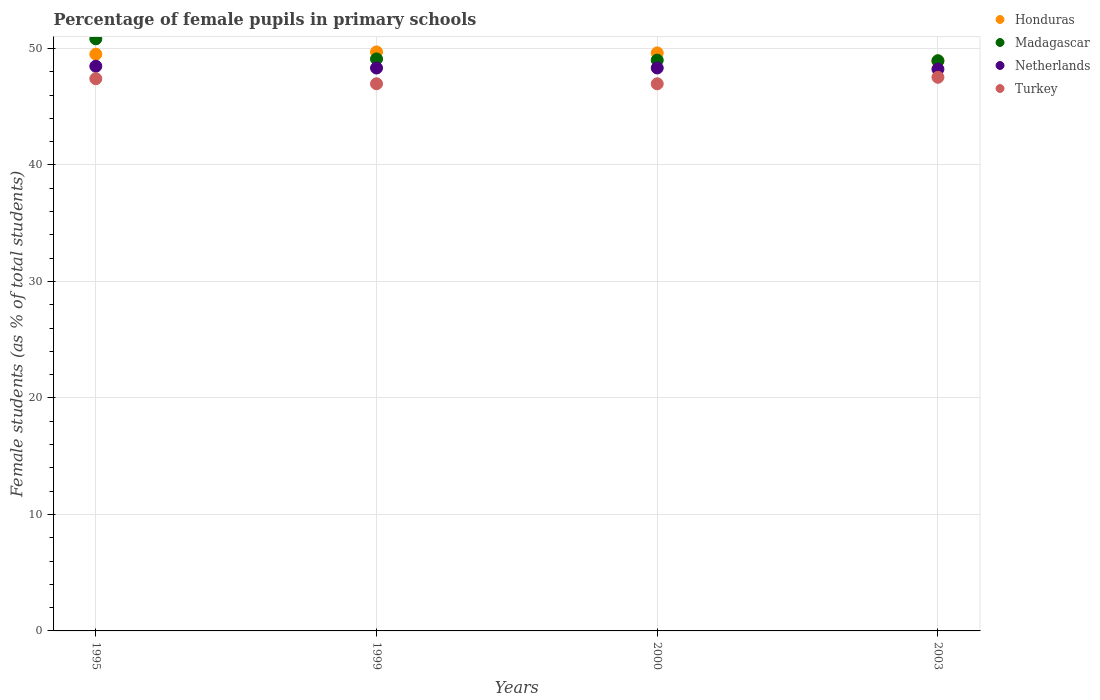How many different coloured dotlines are there?
Make the answer very short. 4. What is the percentage of female pupils in primary schools in Honduras in 1995?
Offer a terse response. 49.51. Across all years, what is the maximum percentage of female pupils in primary schools in Netherlands?
Offer a terse response. 48.47. Across all years, what is the minimum percentage of female pupils in primary schools in Honduras?
Provide a succinct answer. 48.92. In which year was the percentage of female pupils in primary schools in Turkey maximum?
Offer a very short reply. 2003. In which year was the percentage of female pupils in primary schools in Honduras minimum?
Keep it short and to the point. 2003. What is the total percentage of female pupils in primary schools in Turkey in the graph?
Provide a succinct answer. 188.87. What is the difference between the percentage of female pupils in primary schools in Turkey in 1995 and that in 2000?
Your answer should be very brief. 0.44. What is the difference between the percentage of female pupils in primary schools in Turkey in 1995 and the percentage of female pupils in primary schools in Honduras in 2000?
Provide a succinct answer. -2.21. What is the average percentage of female pupils in primary schools in Turkey per year?
Your answer should be compact. 47.22. In the year 1999, what is the difference between the percentage of female pupils in primary schools in Madagascar and percentage of female pupils in primary schools in Honduras?
Provide a short and direct response. -0.6. In how many years, is the percentage of female pupils in primary schools in Netherlands greater than 26 %?
Your answer should be very brief. 4. What is the ratio of the percentage of female pupils in primary schools in Turkey in 1995 to that in 2000?
Your response must be concise. 1.01. What is the difference between the highest and the second highest percentage of female pupils in primary schools in Honduras?
Your answer should be compact. 0.08. What is the difference between the highest and the lowest percentage of female pupils in primary schools in Turkey?
Give a very brief answer. 0.56. Is it the case that in every year, the sum of the percentage of female pupils in primary schools in Turkey and percentage of female pupils in primary schools in Honduras  is greater than the sum of percentage of female pupils in primary schools in Netherlands and percentage of female pupils in primary schools in Madagascar?
Your answer should be compact. No. Is it the case that in every year, the sum of the percentage of female pupils in primary schools in Madagascar and percentage of female pupils in primary schools in Honduras  is greater than the percentage of female pupils in primary schools in Netherlands?
Make the answer very short. Yes. Does the percentage of female pupils in primary schools in Turkey monotonically increase over the years?
Give a very brief answer. No. How many dotlines are there?
Make the answer very short. 4. How many years are there in the graph?
Your answer should be compact. 4. What is the difference between two consecutive major ticks on the Y-axis?
Offer a terse response. 10. Are the values on the major ticks of Y-axis written in scientific E-notation?
Provide a short and direct response. No. Does the graph contain any zero values?
Your response must be concise. No. How are the legend labels stacked?
Offer a terse response. Vertical. What is the title of the graph?
Your answer should be compact. Percentage of female pupils in primary schools. What is the label or title of the X-axis?
Give a very brief answer. Years. What is the label or title of the Y-axis?
Offer a terse response. Female students (as % of total students). What is the Female students (as % of total students) in Honduras in 1995?
Ensure brevity in your answer.  49.51. What is the Female students (as % of total students) of Madagascar in 1995?
Offer a very short reply. 50.83. What is the Female students (as % of total students) of Netherlands in 1995?
Your answer should be compact. 48.47. What is the Female students (as % of total students) of Turkey in 1995?
Provide a short and direct response. 47.4. What is the Female students (as % of total students) in Honduras in 1999?
Ensure brevity in your answer.  49.7. What is the Female students (as % of total students) of Madagascar in 1999?
Keep it short and to the point. 49.1. What is the Female students (as % of total students) of Netherlands in 1999?
Keep it short and to the point. 48.32. What is the Female students (as % of total students) in Turkey in 1999?
Make the answer very short. 46.97. What is the Female students (as % of total students) in Honduras in 2000?
Your response must be concise. 49.62. What is the Female students (as % of total students) of Madagascar in 2000?
Provide a short and direct response. 49. What is the Female students (as % of total students) in Netherlands in 2000?
Your response must be concise. 48.33. What is the Female students (as % of total students) of Turkey in 2000?
Your answer should be very brief. 46.97. What is the Female students (as % of total students) of Honduras in 2003?
Your answer should be very brief. 48.92. What is the Female students (as % of total students) in Madagascar in 2003?
Your response must be concise. 48.95. What is the Female students (as % of total students) in Netherlands in 2003?
Offer a terse response. 48.22. What is the Female students (as % of total students) of Turkey in 2003?
Your answer should be very brief. 47.53. Across all years, what is the maximum Female students (as % of total students) of Honduras?
Offer a terse response. 49.7. Across all years, what is the maximum Female students (as % of total students) of Madagascar?
Ensure brevity in your answer.  50.83. Across all years, what is the maximum Female students (as % of total students) in Netherlands?
Your answer should be compact. 48.47. Across all years, what is the maximum Female students (as % of total students) of Turkey?
Make the answer very short. 47.53. Across all years, what is the minimum Female students (as % of total students) in Honduras?
Offer a terse response. 48.92. Across all years, what is the minimum Female students (as % of total students) of Madagascar?
Ensure brevity in your answer.  48.95. Across all years, what is the minimum Female students (as % of total students) in Netherlands?
Keep it short and to the point. 48.22. Across all years, what is the minimum Female students (as % of total students) of Turkey?
Your answer should be compact. 46.97. What is the total Female students (as % of total students) of Honduras in the graph?
Make the answer very short. 197.75. What is the total Female students (as % of total students) in Madagascar in the graph?
Your answer should be very brief. 197.87. What is the total Female students (as % of total students) in Netherlands in the graph?
Provide a succinct answer. 193.35. What is the total Female students (as % of total students) of Turkey in the graph?
Make the answer very short. 188.87. What is the difference between the Female students (as % of total students) of Honduras in 1995 and that in 1999?
Your response must be concise. -0.19. What is the difference between the Female students (as % of total students) in Madagascar in 1995 and that in 1999?
Your response must be concise. 1.73. What is the difference between the Female students (as % of total students) of Netherlands in 1995 and that in 1999?
Your answer should be compact. 0.15. What is the difference between the Female students (as % of total students) of Turkey in 1995 and that in 1999?
Ensure brevity in your answer.  0.43. What is the difference between the Female students (as % of total students) in Honduras in 1995 and that in 2000?
Give a very brief answer. -0.11. What is the difference between the Female students (as % of total students) of Madagascar in 1995 and that in 2000?
Provide a succinct answer. 1.83. What is the difference between the Female students (as % of total students) in Netherlands in 1995 and that in 2000?
Keep it short and to the point. 0.15. What is the difference between the Female students (as % of total students) in Turkey in 1995 and that in 2000?
Your answer should be compact. 0.44. What is the difference between the Female students (as % of total students) of Honduras in 1995 and that in 2003?
Your answer should be very brief. 0.59. What is the difference between the Female students (as % of total students) in Madagascar in 1995 and that in 2003?
Provide a short and direct response. 1.88. What is the difference between the Female students (as % of total students) in Netherlands in 1995 and that in 2003?
Make the answer very short. 0.25. What is the difference between the Female students (as % of total students) in Turkey in 1995 and that in 2003?
Your response must be concise. -0.12. What is the difference between the Female students (as % of total students) of Honduras in 1999 and that in 2000?
Make the answer very short. 0.08. What is the difference between the Female students (as % of total students) of Madagascar in 1999 and that in 2000?
Make the answer very short. 0.1. What is the difference between the Female students (as % of total students) of Netherlands in 1999 and that in 2000?
Provide a succinct answer. -0. What is the difference between the Female students (as % of total students) of Turkey in 1999 and that in 2000?
Offer a terse response. 0. What is the difference between the Female students (as % of total students) of Honduras in 1999 and that in 2003?
Provide a succinct answer. 0.78. What is the difference between the Female students (as % of total students) in Madagascar in 1999 and that in 2003?
Keep it short and to the point. 0.16. What is the difference between the Female students (as % of total students) in Netherlands in 1999 and that in 2003?
Keep it short and to the point. 0.1. What is the difference between the Female students (as % of total students) in Turkey in 1999 and that in 2003?
Offer a very short reply. -0.56. What is the difference between the Female students (as % of total students) in Honduras in 2000 and that in 2003?
Your answer should be very brief. 0.7. What is the difference between the Female students (as % of total students) of Madagascar in 2000 and that in 2003?
Give a very brief answer. 0.05. What is the difference between the Female students (as % of total students) of Netherlands in 2000 and that in 2003?
Give a very brief answer. 0.1. What is the difference between the Female students (as % of total students) in Turkey in 2000 and that in 2003?
Keep it short and to the point. -0.56. What is the difference between the Female students (as % of total students) in Honduras in 1995 and the Female students (as % of total students) in Madagascar in 1999?
Provide a short and direct response. 0.41. What is the difference between the Female students (as % of total students) in Honduras in 1995 and the Female students (as % of total students) in Netherlands in 1999?
Your answer should be compact. 1.19. What is the difference between the Female students (as % of total students) of Honduras in 1995 and the Female students (as % of total students) of Turkey in 1999?
Give a very brief answer. 2.54. What is the difference between the Female students (as % of total students) of Madagascar in 1995 and the Female students (as % of total students) of Netherlands in 1999?
Provide a succinct answer. 2.51. What is the difference between the Female students (as % of total students) in Madagascar in 1995 and the Female students (as % of total students) in Turkey in 1999?
Give a very brief answer. 3.86. What is the difference between the Female students (as % of total students) in Netherlands in 1995 and the Female students (as % of total students) in Turkey in 1999?
Offer a very short reply. 1.5. What is the difference between the Female students (as % of total students) of Honduras in 1995 and the Female students (as % of total students) of Madagascar in 2000?
Your answer should be compact. 0.51. What is the difference between the Female students (as % of total students) of Honduras in 1995 and the Female students (as % of total students) of Netherlands in 2000?
Make the answer very short. 1.18. What is the difference between the Female students (as % of total students) of Honduras in 1995 and the Female students (as % of total students) of Turkey in 2000?
Offer a very short reply. 2.54. What is the difference between the Female students (as % of total students) in Madagascar in 1995 and the Female students (as % of total students) in Netherlands in 2000?
Your answer should be compact. 2.5. What is the difference between the Female students (as % of total students) in Madagascar in 1995 and the Female students (as % of total students) in Turkey in 2000?
Offer a very short reply. 3.86. What is the difference between the Female students (as % of total students) of Netherlands in 1995 and the Female students (as % of total students) of Turkey in 2000?
Provide a succinct answer. 1.51. What is the difference between the Female students (as % of total students) in Honduras in 1995 and the Female students (as % of total students) in Madagascar in 2003?
Keep it short and to the point. 0.56. What is the difference between the Female students (as % of total students) in Honduras in 1995 and the Female students (as % of total students) in Netherlands in 2003?
Your answer should be very brief. 1.29. What is the difference between the Female students (as % of total students) of Honduras in 1995 and the Female students (as % of total students) of Turkey in 2003?
Offer a very short reply. 1.98. What is the difference between the Female students (as % of total students) in Madagascar in 1995 and the Female students (as % of total students) in Netherlands in 2003?
Offer a very short reply. 2.61. What is the difference between the Female students (as % of total students) of Madagascar in 1995 and the Female students (as % of total students) of Turkey in 2003?
Give a very brief answer. 3.3. What is the difference between the Female students (as % of total students) of Netherlands in 1995 and the Female students (as % of total students) of Turkey in 2003?
Keep it short and to the point. 0.95. What is the difference between the Female students (as % of total students) of Honduras in 1999 and the Female students (as % of total students) of Madagascar in 2000?
Provide a short and direct response. 0.71. What is the difference between the Female students (as % of total students) in Honduras in 1999 and the Female students (as % of total students) in Netherlands in 2000?
Offer a very short reply. 1.38. What is the difference between the Female students (as % of total students) of Honduras in 1999 and the Female students (as % of total students) of Turkey in 2000?
Give a very brief answer. 2.74. What is the difference between the Female students (as % of total students) in Madagascar in 1999 and the Female students (as % of total students) in Netherlands in 2000?
Your response must be concise. 0.77. What is the difference between the Female students (as % of total students) in Madagascar in 1999 and the Female students (as % of total students) in Turkey in 2000?
Offer a very short reply. 2.13. What is the difference between the Female students (as % of total students) of Netherlands in 1999 and the Female students (as % of total students) of Turkey in 2000?
Offer a terse response. 1.35. What is the difference between the Female students (as % of total students) of Honduras in 1999 and the Female students (as % of total students) of Madagascar in 2003?
Ensure brevity in your answer.  0.76. What is the difference between the Female students (as % of total students) of Honduras in 1999 and the Female students (as % of total students) of Netherlands in 2003?
Ensure brevity in your answer.  1.48. What is the difference between the Female students (as % of total students) in Honduras in 1999 and the Female students (as % of total students) in Turkey in 2003?
Make the answer very short. 2.18. What is the difference between the Female students (as % of total students) in Madagascar in 1999 and the Female students (as % of total students) in Netherlands in 2003?
Offer a very short reply. 0.88. What is the difference between the Female students (as % of total students) of Madagascar in 1999 and the Female students (as % of total students) of Turkey in 2003?
Your answer should be compact. 1.57. What is the difference between the Female students (as % of total students) in Netherlands in 1999 and the Female students (as % of total students) in Turkey in 2003?
Make the answer very short. 0.79. What is the difference between the Female students (as % of total students) of Honduras in 2000 and the Female students (as % of total students) of Madagascar in 2003?
Your answer should be compact. 0.67. What is the difference between the Female students (as % of total students) in Honduras in 2000 and the Female students (as % of total students) in Netherlands in 2003?
Provide a succinct answer. 1.4. What is the difference between the Female students (as % of total students) of Honduras in 2000 and the Female students (as % of total students) of Turkey in 2003?
Keep it short and to the point. 2.09. What is the difference between the Female students (as % of total students) in Madagascar in 2000 and the Female students (as % of total students) in Netherlands in 2003?
Your answer should be compact. 0.77. What is the difference between the Female students (as % of total students) of Madagascar in 2000 and the Female students (as % of total students) of Turkey in 2003?
Offer a very short reply. 1.47. What is the difference between the Female students (as % of total students) in Netherlands in 2000 and the Female students (as % of total students) in Turkey in 2003?
Offer a terse response. 0.8. What is the average Female students (as % of total students) in Honduras per year?
Your answer should be compact. 49.44. What is the average Female students (as % of total students) in Madagascar per year?
Keep it short and to the point. 49.47. What is the average Female students (as % of total students) of Netherlands per year?
Provide a short and direct response. 48.34. What is the average Female students (as % of total students) in Turkey per year?
Make the answer very short. 47.22. In the year 1995, what is the difference between the Female students (as % of total students) in Honduras and Female students (as % of total students) in Madagascar?
Keep it short and to the point. -1.32. In the year 1995, what is the difference between the Female students (as % of total students) of Honduras and Female students (as % of total students) of Netherlands?
Provide a succinct answer. 1.04. In the year 1995, what is the difference between the Female students (as % of total students) of Honduras and Female students (as % of total students) of Turkey?
Offer a terse response. 2.11. In the year 1995, what is the difference between the Female students (as % of total students) in Madagascar and Female students (as % of total students) in Netherlands?
Your response must be concise. 2.35. In the year 1995, what is the difference between the Female students (as % of total students) in Madagascar and Female students (as % of total students) in Turkey?
Provide a short and direct response. 3.42. In the year 1995, what is the difference between the Female students (as % of total students) of Netherlands and Female students (as % of total students) of Turkey?
Provide a short and direct response. 1.07. In the year 1999, what is the difference between the Female students (as % of total students) of Honduras and Female students (as % of total students) of Madagascar?
Your answer should be very brief. 0.6. In the year 1999, what is the difference between the Female students (as % of total students) of Honduras and Female students (as % of total students) of Netherlands?
Your answer should be very brief. 1.38. In the year 1999, what is the difference between the Female students (as % of total students) of Honduras and Female students (as % of total students) of Turkey?
Give a very brief answer. 2.73. In the year 1999, what is the difference between the Female students (as % of total students) in Madagascar and Female students (as % of total students) in Netherlands?
Your response must be concise. 0.78. In the year 1999, what is the difference between the Female students (as % of total students) of Madagascar and Female students (as % of total students) of Turkey?
Ensure brevity in your answer.  2.13. In the year 1999, what is the difference between the Female students (as % of total students) of Netherlands and Female students (as % of total students) of Turkey?
Give a very brief answer. 1.35. In the year 2000, what is the difference between the Female students (as % of total students) in Honduras and Female students (as % of total students) in Madagascar?
Your answer should be compact. 0.62. In the year 2000, what is the difference between the Female students (as % of total students) of Honduras and Female students (as % of total students) of Netherlands?
Ensure brevity in your answer.  1.29. In the year 2000, what is the difference between the Female students (as % of total students) of Honduras and Female students (as % of total students) of Turkey?
Make the answer very short. 2.65. In the year 2000, what is the difference between the Female students (as % of total students) of Madagascar and Female students (as % of total students) of Netherlands?
Your response must be concise. 0.67. In the year 2000, what is the difference between the Female students (as % of total students) in Madagascar and Female students (as % of total students) in Turkey?
Provide a succinct answer. 2.03. In the year 2000, what is the difference between the Female students (as % of total students) in Netherlands and Female students (as % of total students) in Turkey?
Your answer should be compact. 1.36. In the year 2003, what is the difference between the Female students (as % of total students) of Honduras and Female students (as % of total students) of Madagascar?
Your answer should be very brief. -0.02. In the year 2003, what is the difference between the Female students (as % of total students) of Honduras and Female students (as % of total students) of Netherlands?
Your response must be concise. 0.7. In the year 2003, what is the difference between the Female students (as % of total students) of Honduras and Female students (as % of total students) of Turkey?
Give a very brief answer. 1.4. In the year 2003, what is the difference between the Female students (as % of total students) of Madagascar and Female students (as % of total students) of Netherlands?
Your answer should be very brief. 0.72. In the year 2003, what is the difference between the Female students (as % of total students) in Madagascar and Female students (as % of total students) in Turkey?
Offer a very short reply. 1.42. In the year 2003, what is the difference between the Female students (as % of total students) of Netherlands and Female students (as % of total students) of Turkey?
Ensure brevity in your answer.  0.7. What is the ratio of the Female students (as % of total students) of Honduras in 1995 to that in 1999?
Make the answer very short. 1. What is the ratio of the Female students (as % of total students) in Madagascar in 1995 to that in 1999?
Make the answer very short. 1.04. What is the ratio of the Female students (as % of total students) in Turkey in 1995 to that in 1999?
Your answer should be compact. 1.01. What is the ratio of the Female students (as % of total students) of Honduras in 1995 to that in 2000?
Your response must be concise. 1. What is the ratio of the Female students (as % of total students) of Madagascar in 1995 to that in 2000?
Your response must be concise. 1.04. What is the ratio of the Female students (as % of total students) in Turkey in 1995 to that in 2000?
Keep it short and to the point. 1.01. What is the ratio of the Female students (as % of total students) of Honduras in 1995 to that in 2003?
Your response must be concise. 1.01. What is the ratio of the Female students (as % of total students) in Madagascar in 1995 to that in 2003?
Offer a very short reply. 1.04. What is the ratio of the Female students (as % of total students) of Turkey in 1995 to that in 2003?
Offer a terse response. 1. What is the ratio of the Female students (as % of total students) in Netherlands in 1999 to that in 2000?
Provide a succinct answer. 1. What is the ratio of the Female students (as % of total students) of Madagascar in 1999 to that in 2003?
Give a very brief answer. 1. What is the ratio of the Female students (as % of total students) of Netherlands in 1999 to that in 2003?
Provide a short and direct response. 1. What is the ratio of the Female students (as % of total students) in Turkey in 1999 to that in 2003?
Your answer should be very brief. 0.99. What is the ratio of the Female students (as % of total students) of Honduras in 2000 to that in 2003?
Your answer should be compact. 1.01. What is the ratio of the Female students (as % of total students) of Madagascar in 2000 to that in 2003?
Ensure brevity in your answer.  1. What is the difference between the highest and the second highest Female students (as % of total students) in Honduras?
Offer a very short reply. 0.08. What is the difference between the highest and the second highest Female students (as % of total students) in Madagascar?
Your answer should be compact. 1.73. What is the difference between the highest and the second highest Female students (as % of total students) in Netherlands?
Offer a terse response. 0.15. What is the difference between the highest and the second highest Female students (as % of total students) of Turkey?
Provide a short and direct response. 0.12. What is the difference between the highest and the lowest Female students (as % of total students) of Honduras?
Your answer should be very brief. 0.78. What is the difference between the highest and the lowest Female students (as % of total students) of Madagascar?
Give a very brief answer. 1.88. What is the difference between the highest and the lowest Female students (as % of total students) of Netherlands?
Keep it short and to the point. 0.25. What is the difference between the highest and the lowest Female students (as % of total students) of Turkey?
Provide a short and direct response. 0.56. 